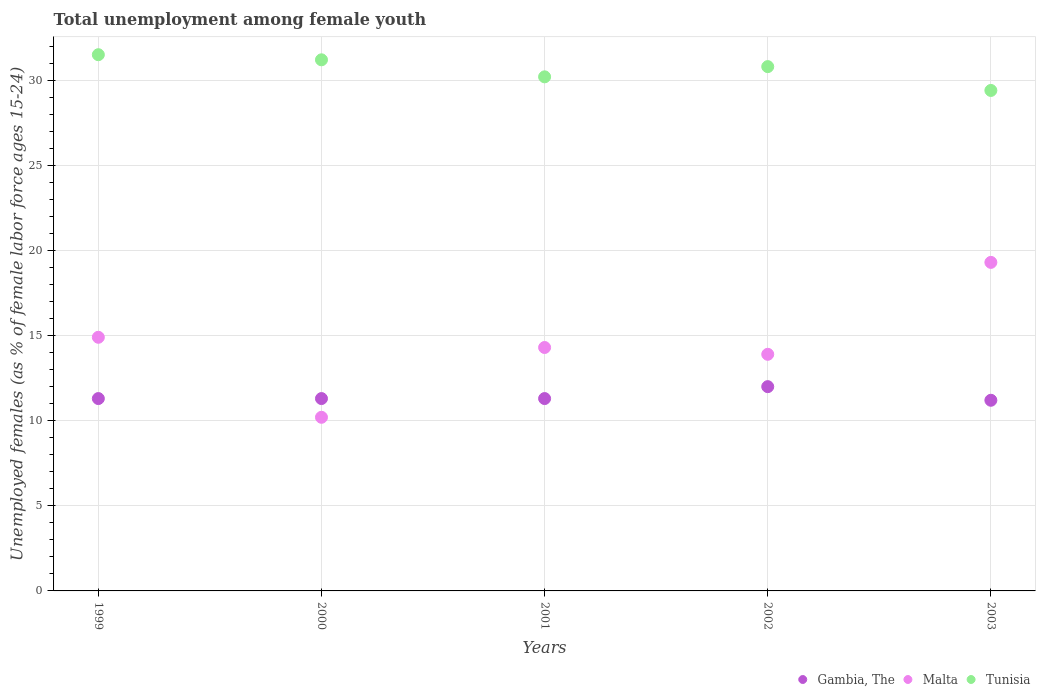How many different coloured dotlines are there?
Provide a succinct answer. 3. Is the number of dotlines equal to the number of legend labels?
Offer a terse response. Yes. What is the percentage of unemployed females in in Gambia, The in 2000?
Keep it short and to the point. 11.3. Across all years, what is the maximum percentage of unemployed females in in Tunisia?
Your answer should be very brief. 31.5. Across all years, what is the minimum percentage of unemployed females in in Malta?
Offer a terse response. 10.2. In which year was the percentage of unemployed females in in Malta minimum?
Your response must be concise. 2000. What is the total percentage of unemployed females in in Malta in the graph?
Offer a very short reply. 72.6. What is the difference between the percentage of unemployed females in in Tunisia in 2000 and the percentage of unemployed females in in Gambia, The in 2001?
Ensure brevity in your answer.  19.9. What is the average percentage of unemployed females in in Malta per year?
Ensure brevity in your answer.  14.52. In the year 2002, what is the difference between the percentage of unemployed females in in Tunisia and percentage of unemployed females in in Gambia, The?
Your answer should be compact. 18.8. What is the ratio of the percentage of unemployed females in in Tunisia in 1999 to that in 2003?
Make the answer very short. 1.07. Is the difference between the percentage of unemployed females in in Tunisia in 2000 and 2002 greater than the difference between the percentage of unemployed females in in Gambia, The in 2000 and 2002?
Give a very brief answer. Yes. What is the difference between the highest and the second highest percentage of unemployed females in in Tunisia?
Your answer should be compact. 0.3. What is the difference between the highest and the lowest percentage of unemployed females in in Malta?
Your answer should be very brief. 9.1. In how many years, is the percentage of unemployed females in in Malta greater than the average percentage of unemployed females in in Malta taken over all years?
Give a very brief answer. 2. Is the percentage of unemployed females in in Tunisia strictly less than the percentage of unemployed females in in Gambia, The over the years?
Your response must be concise. No. How many years are there in the graph?
Ensure brevity in your answer.  5. What is the difference between two consecutive major ticks on the Y-axis?
Your answer should be compact. 5. Are the values on the major ticks of Y-axis written in scientific E-notation?
Ensure brevity in your answer.  No. Does the graph contain grids?
Offer a terse response. Yes. What is the title of the graph?
Ensure brevity in your answer.  Total unemployment among female youth. What is the label or title of the Y-axis?
Your response must be concise. Unemployed females (as % of female labor force ages 15-24). What is the Unemployed females (as % of female labor force ages 15-24) of Gambia, The in 1999?
Make the answer very short. 11.3. What is the Unemployed females (as % of female labor force ages 15-24) in Malta in 1999?
Ensure brevity in your answer.  14.9. What is the Unemployed females (as % of female labor force ages 15-24) in Tunisia in 1999?
Provide a succinct answer. 31.5. What is the Unemployed females (as % of female labor force ages 15-24) in Gambia, The in 2000?
Make the answer very short. 11.3. What is the Unemployed females (as % of female labor force ages 15-24) in Malta in 2000?
Offer a very short reply. 10.2. What is the Unemployed females (as % of female labor force ages 15-24) of Tunisia in 2000?
Provide a succinct answer. 31.2. What is the Unemployed females (as % of female labor force ages 15-24) of Gambia, The in 2001?
Provide a short and direct response. 11.3. What is the Unemployed females (as % of female labor force ages 15-24) of Malta in 2001?
Your response must be concise. 14.3. What is the Unemployed females (as % of female labor force ages 15-24) of Tunisia in 2001?
Make the answer very short. 30.2. What is the Unemployed females (as % of female labor force ages 15-24) in Gambia, The in 2002?
Keep it short and to the point. 12. What is the Unemployed females (as % of female labor force ages 15-24) in Malta in 2002?
Your response must be concise. 13.9. What is the Unemployed females (as % of female labor force ages 15-24) in Tunisia in 2002?
Make the answer very short. 30.8. What is the Unemployed females (as % of female labor force ages 15-24) of Gambia, The in 2003?
Offer a terse response. 11.2. What is the Unemployed females (as % of female labor force ages 15-24) in Malta in 2003?
Ensure brevity in your answer.  19.3. What is the Unemployed females (as % of female labor force ages 15-24) of Tunisia in 2003?
Keep it short and to the point. 29.4. Across all years, what is the maximum Unemployed females (as % of female labor force ages 15-24) in Gambia, The?
Give a very brief answer. 12. Across all years, what is the maximum Unemployed females (as % of female labor force ages 15-24) in Malta?
Offer a very short reply. 19.3. Across all years, what is the maximum Unemployed females (as % of female labor force ages 15-24) in Tunisia?
Your answer should be very brief. 31.5. Across all years, what is the minimum Unemployed females (as % of female labor force ages 15-24) of Gambia, The?
Your response must be concise. 11.2. Across all years, what is the minimum Unemployed females (as % of female labor force ages 15-24) in Malta?
Give a very brief answer. 10.2. Across all years, what is the minimum Unemployed females (as % of female labor force ages 15-24) in Tunisia?
Your answer should be very brief. 29.4. What is the total Unemployed females (as % of female labor force ages 15-24) of Gambia, The in the graph?
Offer a very short reply. 57.1. What is the total Unemployed females (as % of female labor force ages 15-24) of Malta in the graph?
Offer a very short reply. 72.6. What is the total Unemployed females (as % of female labor force ages 15-24) in Tunisia in the graph?
Provide a short and direct response. 153.1. What is the difference between the Unemployed females (as % of female labor force ages 15-24) of Malta in 1999 and that in 2000?
Give a very brief answer. 4.7. What is the difference between the Unemployed females (as % of female labor force ages 15-24) in Tunisia in 1999 and that in 2000?
Your response must be concise. 0.3. What is the difference between the Unemployed females (as % of female labor force ages 15-24) in Malta in 1999 and that in 2001?
Your response must be concise. 0.6. What is the difference between the Unemployed females (as % of female labor force ages 15-24) of Tunisia in 1999 and that in 2001?
Your answer should be compact. 1.3. What is the difference between the Unemployed females (as % of female labor force ages 15-24) in Gambia, The in 1999 and that in 2002?
Your answer should be compact. -0.7. What is the difference between the Unemployed females (as % of female labor force ages 15-24) of Gambia, The in 1999 and that in 2003?
Your response must be concise. 0.1. What is the difference between the Unemployed females (as % of female labor force ages 15-24) of Tunisia in 1999 and that in 2003?
Ensure brevity in your answer.  2.1. What is the difference between the Unemployed females (as % of female labor force ages 15-24) in Gambia, The in 2000 and that in 2001?
Your answer should be compact. 0. What is the difference between the Unemployed females (as % of female labor force ages 15-24) of Gambia, The in 2000 and that in 2002?
Ensure brevity in your answer.  -0.7. What is the difference between the Unemployed females (as % of female labor force ages 15-24) of Malta in 2000 and that in 2002?
Your answer should be very brief. -3.7. What is the difference between the Unemployed females (as % of female labor force ages 15-24) of Tunisia in 2000 and that in 2002?
Offer a very short reply. 0.4. What is the difference between the Unemployed females (as % of female labor force ages 15-24) of Tunisia in 2001 and that in 2003?
Your answer should be compact. 0.8. What is the difference between the Unemployed females (as % of female labor force ages 15-24) in Malta in 2002 and that in 2003?
Keep it short and to the point. -5.4. What is the difference between the Unemployed females (as % of female labor force ages 15-24) of Tunisia in 2002 and that in 2003?
Your answer should be compact. 1.4. What is the difference between the Unemployed females (as % of female labor force ages 15-24) in Gambia, The in 1999 and the Unemployed females (as % of female labor force ages 15-24) in Tunisia in 2000?
Your answer should be compact. -19.9. What is the difference between the Unemployed females (as % of female labor force ages 15-24) of Malta in 1999 and the Unemployed females (as % of female labor force ages 15-24) of Tunisia in 2000?
Ensure brevity in your answer.  -16.3. What is the difference between the Unemployed females (as % of female labor force ages 15-24) of Gambia, The in 1999 and the Unemployed females (as % of female labor force ages 15-24) of Malta in 2001?
Ensure brevity in your answer.  -3. What is the difference between the Unemployed females (as % of female labor force ages 15-24) of Gambia, The in 1999 and the Unemployed females (as % of female labor force ages 15-24) of Tunisia in 2001?
Provide a succinct answer. -18.9. What is the difference between the Unemployed females (as % of female labor force ages 15-24) in Malta in 1999 and the Unemployed females (as % of female labor force ages 15-24) in Tunisia in 2001?
Offer a terse response. -15.3. What is the difference between the Unemployed females (as % of female labor force ages 15-24) of Gambia, The in 1999 and the Unemployed females (as % of female labor force ages 15-24) of Tunisia in 2002?
Offer a terse response. -19.5. What is the difference between the Unemployed females (as % of female labor force ages 15-24) of Malta in 1999 and the Unemployed females (as % of female labor force ages 15-24) of Tunisia in 2002?
Your response must be concise. -15.9. What is the difference between the Unemployed females (as % of female labor force ages 15-24) in Gambia, The in 1999 and the Unemployed females (as % of female labor force ages 15-24) in Malta in 2003?
Your response must be concise. -8. What is the difference between the Unemployed females (as % of female labor force ages 15-24) of Gambia, The in 1999 and the Unemployed females (as % of female labor force ages 15-24) of Tunisia in 2003?
Your answer should be compact. -18.1. What is the difference between the Unemployed females (as % of female labor force ages 15-24) of Malta in 1999 and the Unemployed females (as % of female labor force ages 15-24) of Tunisia in 2003?
Provide a short and direct response. -14.5. What is the difference between the Unemployed females (as % of female labor force ages 15-24) in Gambia, The in 2000 and the Unemployed females (as % of female labor force ages 15-24) in Tunisia in 2001?
Ensure brevity in your answer.  -18.9. What is the difference between the Unemployed females (as % of female labor force ages 15-24) in Gambia, The in 2000 and the Unemployed females (as % of female labor force ages 15-24) in Tunisia in 2002?
Your answer should be very brief. -19.5. What is the difference between the Unemployed females (as % of female labor force ages 15-24) in Malta in 2000 and the Unemployed females (as % of female labor force ages 15-24) in Tunisia in 2002?
Your response must be concise. -20.6. What is the difference between the Unemployed females (as % of female labor force ages 15-24) of Gambia, The in 2000 and the Unemployed females (as % of female labor force ages 15-24) of Tunisia in 2003?
Offer a terse response. -18.1. What is the difference between the Unemployed females (as % of female labor force ages 15-24) of Malta in 2000 and the Unemployed females (as % of female labor force ages 15-24) of Tunisia in 2003?
Provide a short and direct response. -19.2. What is the difference between the Unemployed females (as % of female labor force ages 15-24) of Gambia, The in 2001 and the Unemployed females (as % of female labor force ages 15-24) of Malta in 2002?
Ensure brevity in your answer.  -2.6. What is the difference between the Unemployed females (as % of female labor force ages 15-24) in Gambia, The in 2001 and the Unemployed females (as % of female labor force ages 15-24) in Tunisia in 2002?
Ensure brevity in your answer.  -19.5. What is the difference between the Unemployed females (as % of female labor force ages 15-24) in Malta in 2001 and the Unemployed females (as % of female labor force ages 15-24) in Tunisia in 2002?
Give a very brief answer. -16.5. What is the difference between the Unemployed females (as % of female labor force ages 15-24) of Gambia, The in 2001 and the Unemployed females (as % of female labor force ages 15-24) of Malta in 2003?
Your answer should be very brief. -8. What is the difference between the Unemployed females (as % of female labor force ages 15-24) in Gambia, The in 2001 and the Unemployed females (as % of female labor force ages 15-24) in Tunisia in 2003?
Provide a succinct answer. -18.1. What is the difference between the Unemployed females (as % of female labor force ages 15-24) of Malta in 2001 and the Unemployed females (as % of female labor force ages 15-24) of Tunisia in 2003?
Provide a succinct answer. -15.1. What is the difference between the Unemployed females (as % of female labor force ages 15-24) of Gambia, The in 2002 and the Unemployed females (as % of female labor force ages 15-24) of Malta in 2003?
Provide a short and direct response. -7.3. What is the difference between the Unemployed females (as % of female labor force ages 15-24) of Gambia, The in 2002 and the Unemployed females (as % of female labor force ages 15-24) of Tunisia in 2003?
Offer a very short reply. -17.4. What is the difference between the Unemployed females (as % of female labor force ages 15-24) in Malta in 2002 and the Unemployed females (as % of female labor force ages 15-24) in Tunisia in 2003?
Your response must be concise. -15.5. What is the average Unemployed females (as % of female labor force ages 15-24) of Gambia, The per year?
Provide a succinct answer. 11.42. What is the average Unemployed females (as % of female labor force ages 15-24) of Malta per year?
Your response must be concise. 14.52. What is the average Unemployed females (as % of female labor force ages 15-24) in Tunisia per year?
Provide a short and direct response. 30.62. In the year 1999, what is the difference between the Unemployed females (as % of female labor force ages 15-24) of Gambia, The and Unemployed females (as % of female labor force ages 15-24) of Tunisia?
Offer a very short reply. -20.2. In the year 1999, what is the difference between the Unemployed females (as % of female labor force ages 15-24) in Malta and Unemployed females (as % of female labor force ages 15-24) in Tunisia?
Your answer should be compact. -16.6. In the year 2000, what is the difference between the Unemployed females (as % of female labor force ages 15-24) of Gambia, The and Unemployed females (as % of female labor force ages 15-24) of Malta?
Your answer should be very brief. 1.1. In the year 2000, what is the difference between the Unemployed females (as % of female labor force ages 15-24) of Gambia, The and Unemployed females (as % of female labor force ages 15-24) of Tunisia?
Provide a succinct answer. -19.9. In the year 2000, what is the difference between the Unemployed females (as % of female labor force ages 15-24) in Malta and Unemployed females (as % of female labor force ages 15-24) in Tunisia?
Your answer should be very brief. -21. In the year 2001, what is the difference between the Unemployed females (as % of female labor force ages 15-24) of Gambia, The and Unemployed females (as % of female labor force ages 15-24) of Tunisia?
Ensure brevity in your answer.  -18.9. In the year 2001, what is the difference between the Unemployed females (as % of female labor force ages 15-24) of Malta and Unemployed females (as % of female labor force ages 15-24) of Tunisia?
Your answer should be very brief. -15.9. In the year 2002, what is the difference between the Unemployed females (as % of female labor force ages 15-24) in Gambia, The and Unemployed females (as % of female labor force ages 15-24) in Tunisia?
Your answer should be compact. -18.8. In the year 2002, what is the difference between the Unemployed females (as % of female labor force ages 15-24) of Malta and Unemployed females (as % of female labor force ages 15-24) of Tunisia?
Keep it short and to the point. -16.9. In the year 2003, what is the difference between the Unemployed females (as % of female labor force ages 15-24) in Gambia, The and Unemployed females (as % of female labor force ages 15-24) in Malta?
Provide a succinct answer. -8.1. In the year 2003, what is the difference between the Unemployed females (as % of female labor force ages 15-24) in Gambia, The and Unemployed females (as % of female labor force ages 15-24) in Tunisia?
Your answer should be very brief. -18.2. What is the ratio of the Unemployed females (as % of female labor force ages 15-24) in Malta in 1999 to that in 2000?
Your response must be concise. 1.46. What is the ratio of the Unemployed females (as % of female labor force ages 15-24) in Tunisia in 1999 to that in 2000?
Provide a short and direct response. 1.01. What is the ratio of the Unemployed females (as % of female labor force ages 15-24) of Gambia, The in 1999 to that in 2001?
Give a very brief answer. 1. What is the ratio of the Unemployed females (as % of female labor force ages 15-24) of Malta in 1999 to that in 2001?
Your answer should be very brief. 1.04. What is the ratio of the Unemployed females (as % of female labor force ages 15-24) in Tunisia in 1999 to that in 2001?
Offer a very short reply. 1.04. What is the ratio of the Unemployed females (as % of female labor force ages 15-24) in Gambia, The in 1999 to that in 2002?
Make the answer very short. 0.94. What is the ratio of the Unemployed females (as % of female labor force ages 15-24) in Malta in 1999 to that in 2002?
Give a very brief answer. 1.07. What is the ratio of the Unemployed females (as % of female labor force ages 15-24) of Tunisia in 1999 to that in 2002?
Ensure brevity in your answer.  1.02. What is the ratio of the Unemployed females (as % of female labor force ages 15-24) of Gambia, The in 1999 to that in 2003?
Your answer should be very brief. 1.01. What is the ratio of the Unemployed females (as % of female labor force ages 15-24) in Malta in 1999 to that in 2003?
Ensure brevity in your answer.  0.77. What is the ratio of the Unemployed females (as % of female labor force ages 15-24) in Tunisia in 1999 to that in 2003?
Provide a short and direct response. 1.07. What is the ratio of the Unemployed females (as % of female labor force ages 15-24) in Malta in 2000 to that in 2001?
Offer a very short reply. 0.71. What is the ratio of the Unemployed females (as % of female labor force ages 15-24) of Tunisia in 2000 to that in 2001?
Provide a succinct answer. 1.03. What is the ratio of the Unemployed females (as % of female labor force ages 15-24) of Gambia, The in 2000 to that in 2002?
Provide a succinct answer. 0.94. What is the ratio of the Unemployed females (as % of female labor force ages 15-24) in Malta in 2000 to that in 2002?
Your answer should be very brief. 0.73. What is the ratio of the Unemployed females (as % of female labor force ages 15-24) in Gambia, The in 2000 to that in 2003?
Offer a very short reply. 1.01. What is the ratio of the Unemployed females (as % of female labor force ages 15-24) in Malta in 2000 to that in 2003?
Ensure brevity in your answer.  0.53. What is the ratio of the Unemployed females (as % of female labor force ages 15-24) in Tunisia in 2000 to that in 2003?
Ensure brevity in your answer.  1.06. What is the ratio of the Unemployed females (as % of female labor force ages 15-24) in Gambia, The in 2001 to that in 2002?
Your answer should be very brief. 0.94. What is the ratio of the Unemployed females (as % of female labor force ages 15-24) in Malta in 2001 to that in 2002?
Provide a succinct answer. 1.03. What is the ratio of the Unemployed females (as % of female labor force ages 15-24) of Tunisia in 2001 to that in 2002?
Your response must be concise. 0.98. What is the ratio of the Unemployed females (as % of female labor force ages 15-24) of Gambia, The in 2001 to that in 2003?
Offer a very short reply. 1.01. What is the ratio of the Unemployed females (as % of female labor force ages 15-24) of Malta in 2001 to that in 2003?
Offer a very short reply. 0.74. What is the ratio of the Unemployed females (as % of female labor force ages 15-24) of Tunisia in 2001 to that in 2003?
Offer a terse response. 1.03. What is the ratio of the Unemployed females (as % of female labor force ages 15-24) of Gambia, The in 2002 to that in 2003?
Provide a succinct answer. 1.07. What is the ratio of the Unemployed females (as % of female labor force ages 15-24) in Malta in 2002 to that in 2003?
Your answer should be very brief. 0.72. What is the ratio of the Unemployed females (as % of female labor force ages 15-24) of Tunisia in 2002 to that in 2003?
Keep it short and to the point. 1.05. What is the difference between the highest and the second highest Unemployed females (as % of female labor force ages 15-24) in Gambia, The?
Ensure brevity in your answer.  0.7. What is the difference between the highest and the second highest Unemployed females (as % of female labor force ages 15-24) in Malta?
Offer a very short reply. 4.4. What is the difference between the highest and the second highest Unemployed females (as % of female labor force ages 15-24) of Tunisia?
Your answer should be compact. 0.3. What is the difference between the highest and the lowest Unemployed females (as % of female labor force ages 15-24) of Malta?
Provide a succinct answer. 9.1. What is the difference between the highest and the lowest Unemployed females (as % of female labor force ages 15-24) in Tunisia?
Ensure brevity in your answer.  2.1. 